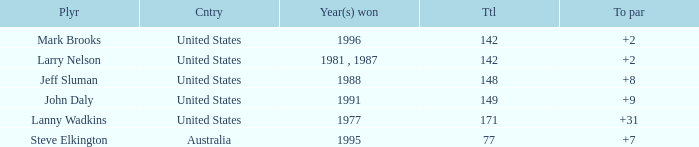Name the Total of australia and a To par smaller than 7? None. 